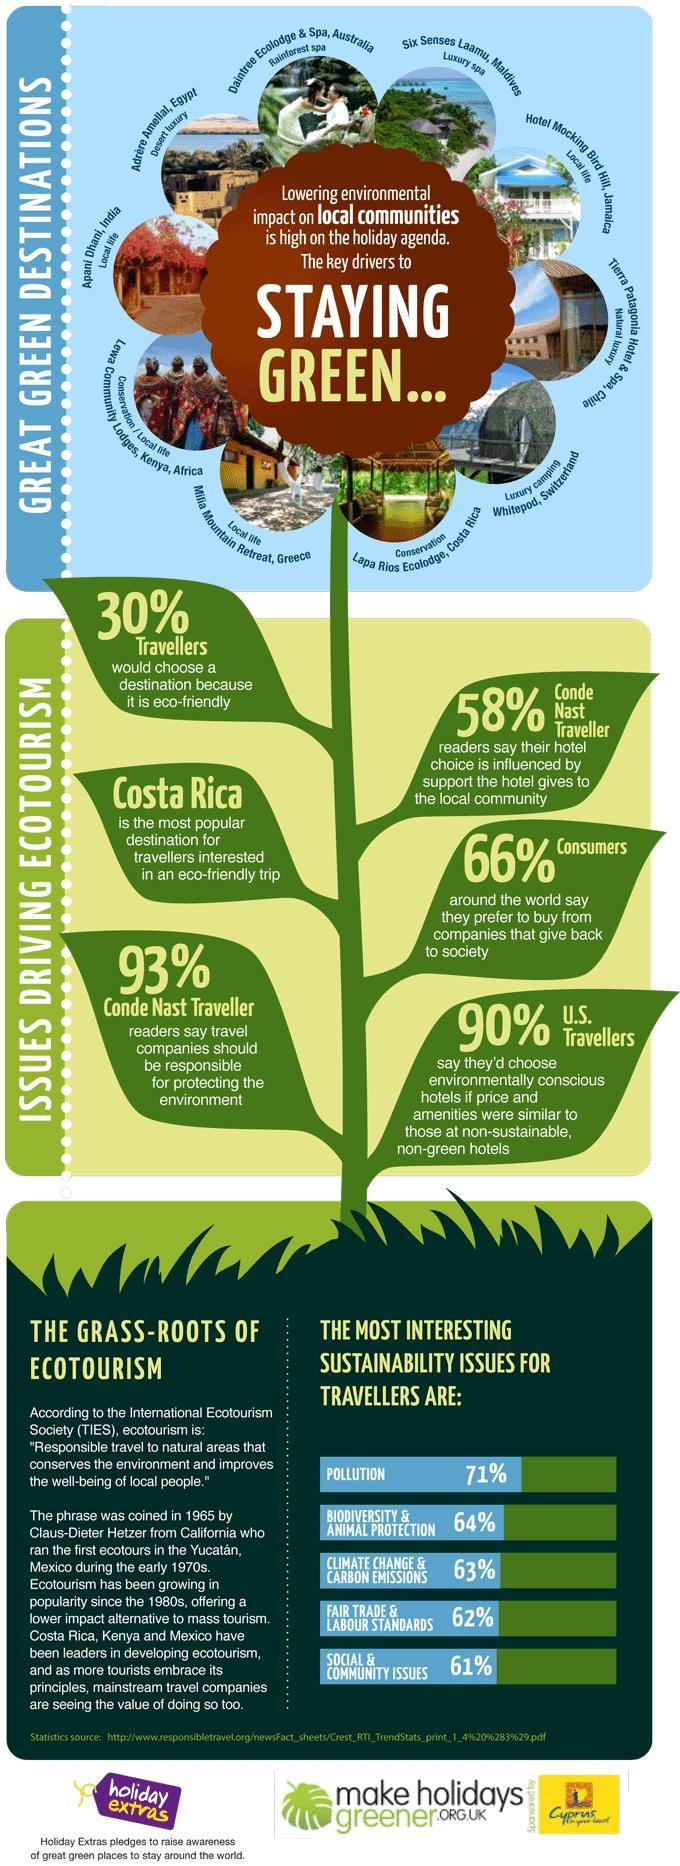What percentage of consumers prefer to buy from companies that give back to society?
Answer the question with a short phrase. 66% What is the percentage of pollution and Fairtrade & Labour Standards that affect travelers? 133% What percentage of travelers choose eco-friendly destinations? 30% 